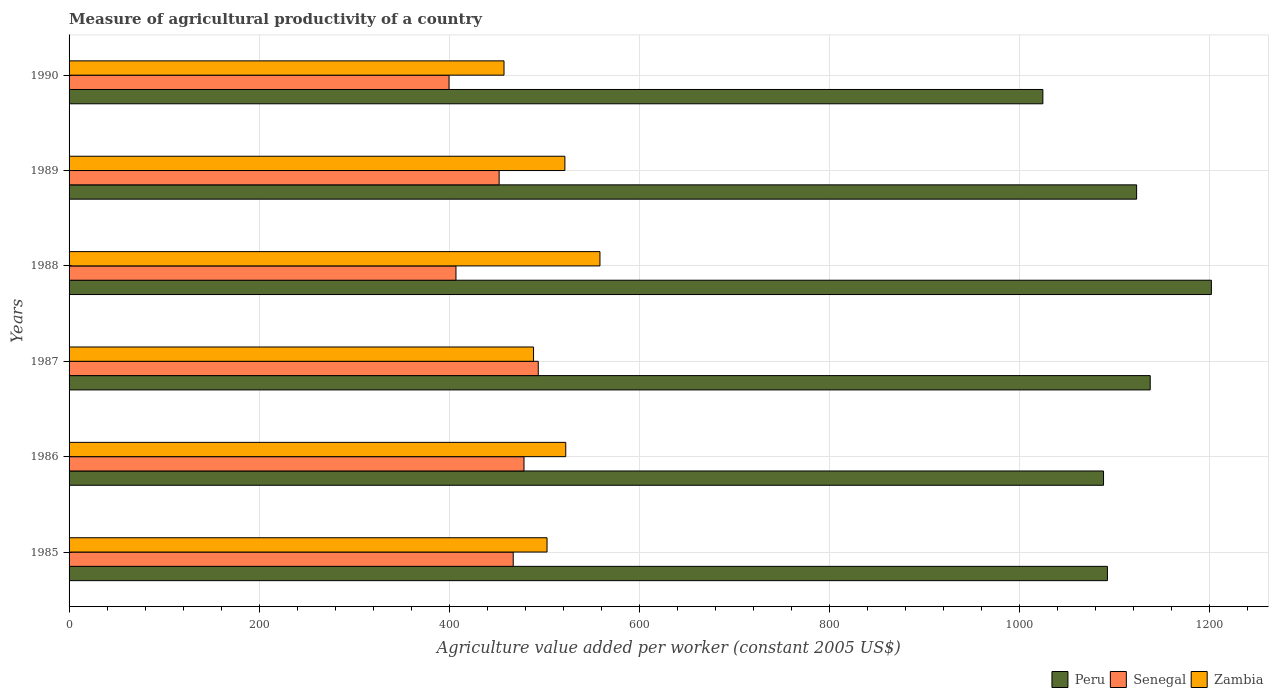How many different coloured bars are there?
Provide a short and direct response. 3. Are the number of bars on each tick of the Y-axis equal?
Offer a terse response. Yes. How many bars are there on the 4th tick from the top?
Keep it short and to the point. 3. What is the label of the 1st group of bars from the top?
Offer a terse response. 1990. What is the measure of agricultural productivity in Senegal in 1990?
Make the answer very short. 399.78. Across all years, what is the maximum measure of agricultural productivity in Senegal?
Give a very brief answer. 493.64. Across all years, what is the minimum measure of agricultural productivity in Zambia?
Provide a short and direct response. 457.6. What is the total measure of agricultural productivity in Senegal in the graph?
Provide a short and direct response. 2698.88. What is the difference between the measure of agricultural productivity in Peru in 1986 and that in 1987?
Give a very brief answer. -49.12. What is the difference between the measure of agricultural productivity in Senegal in 1985 and the measure of agricultural productivity in Zambia in 1989?
Your response must be concise. -54.36. What is the average measure of agricultural productivity in Zambia per year?
Offer a very short reply. 508.65. In the year 1988, what is the difference between the measure of agricultural productivity in Senegal and measure of agricultural productivity in Zambia?
Give a very brief answer. -151.48. In how many years, is the measure of agricultural productivity in Peru greater than 1080 US$?
Provide a succinct answer. 5. What is the ratio of the measure of agricultural productivity in Zambia in 1985 to that in 1987?
Provide a succinct answer. 1.03. Is the measure of agricultural productivity in Zambia in 1986 less than that in 1988?
Provide a short and direct response. Yes. Is the difference between the measure of agricultural productivity in Senegal in 1986 and 1987 greater than the difference between the measure of agricultural productivity in Zambia in 1986 and 1987?
Your answer should be compact. No. What is the difference between the highest and the second highest measure of agricultural productivity in Zambia?
Offer a very short reply. 35.99. What is the difference between the highest and the lowest measure of agricultural productivity in Senegal?
Your response must be concise. 93.86. Is the sum of the measure of agricultural productivity in Senegal in 1989 and 1990 greater than the maximum measure of agricultural productivity in Peru across all years?
Your answer should be very brief. No. Is it the case that in every year, the sum of the measure of agricultural productivity in Zambia and measure of agricultural productivity in Peru is greater than the measure of agricultural productivity in Senegal?
Your answer should be very brief. Yes. Does the graph contain any zero values?
Your answer should be compact. No. Does the graph contain grids?
Give a very brief answer. Yes. How many legend labels are there?
Keep it short and to the point. 3. How are the legend labels stacked?
Ensure brevity in your answer.  Horizontal. What is the title of the graph?
Give a very brief answer. Measure of agricultural productivity of a country. Does "Small states" appear as one of the legend labels in the graph?
Provide a short and direct response. No. What is the label or title of the X-axis?
Make the answer very short. Agriculture value added per worker (constant 2005 US$). What is the label or title of the Y-axis?
Your answer should be very brief. Years. What is the Agriculture value added per worker (constant 2005 US$) in Peru in 1985?
Keep it short and to the point. 1092.45. What is the Agriculture value added per worker (constant 2005 US$) in Senegal in 1985?
Your response must be concise. 467.29. What is the Agriculture value added per worker (constant 2005 US$) in Zambia in 1985?
Give a very brief answer. 502.87. What is the Agriculture value added per worker (constant 2005 US$) of Peru in 1986?
Your answer should be compact. 1088.36. What is the Agriculture value added per worker (constant 2005 US$) of Senegal in 1986?
Make the answer very short. 478.63. What is the Agriculture value added per worker (constant 2005 US$) of Zambia in 1986?
Keep it short and to the point. 522.55. What is the Agriculture value added per worker (constant 2005 US$) of Peru in 1987?
Offer a very short reply. 1137.48. What is the Agriculture value added per worker (constant 2005 US$) in Senegal in 1987?
Ensure brevity in your answer.  493.64. What is the Agriculture value added per worker (constant 2005 US$) of Zambia in 1987?
Provide a succinct answer. 488.67. What is the Agriculture value added per worker (constant 2005 US$) in Peru in 1988?
Offer a terse response. 1201.82. What is the Agriculture value added per worker (constant 2005 US$) of Senegal in 1988?
Your answer should be compact. 407.06. What is the Agriculture value added per worker (constant 2005 US$) of Zambia in 1988?
Ensure brevity in your answer.  558.54. What is the Agriculture value added per worker (constant 2005 US$) in Peru in 1989?
Give a very brief answer. 1123.18. What is the Agriculture value added per worker (constant 2005 US$) of Senegal in 1989?
Provide a short and direct response. 452.48. What is the Agriculture value added per worker (constant 2005 US$) of Zambia in 1989?
Ensure brevity in your answer.  521.65. What is the Agriculture value added per worker (constant 2005 US$) of Peru in 1990?
Provide a short and direct response. 1024.55. What is the Agriculture value added per worker (constant 2005 US$) of Senegal in 1990?
Your answer should be compact. 399.78. What is the Agriculture value added per worker (constant 2005 US$) in Zambia in 1990?
Your response must be concise. 457.6. Across all years, what is the maximum Agriculture value added per worker (constant 2005 US$) in Peru?
Your answer should be very brief. 1201.82. Across all years, what is the maximum Agriculture value added per worker (constant 2005 US$) of Senegal?
Your response must be concise. 493.64. Across all years, what is the maximum Agriculture value added per worker (constant 2005 US$) in Zambia?
Make the answer very short. 558.54. Across all years, what is the minimum Agriculture value added per worker (constant 2005 US$) in Peru?
Your answer should be compact. 1024.55. Across all years, what is the minimum Agriculture value added per worker (constant 2005 US$) of Senegal?
Provide a short and direct response. 399.78. Across all years, what is the minimum Agriculture value added per worker (constant 2005 US$) of Zambia?
Give a very brief answer. 457.6. What is the total Agriculture value added per worker (constant 2005 US$) of Peru in the graph?
Your answer should be compact. 6667.84. What is the total Agriculture value added per worker (constant 2005 US$) in Senegal in the graph?
Offer a very short reply. 2698.88. What is the total Agriculture value added per worker (constant 2005 US$) in Zambia in the graph?
Provide a succinct answer. 3051.89. What is the difference between the Agriculture value added per worker (constant 2005 US$) of Peru in 1985 and that in 1986?
Provide a short and direct response. 4.08. What is the difference between the Agriculture value added per worker (constant 2005 US$) of Senegal in 1985 and that in 1986?
Your answer should be compact. -11.34. What is the difference between the Agriculture value added per worker (constant 2005 US$) in Zambia in 1985 and that in 1986?
Provide a succinct answer. -19.68. What is the difference between the Agriculture value added per worker (constant 2005 US$) in Peru in 1985 and that in 1987?
Provide a short and direct response. -45.03. What is the difference between the Agriculture value added per worker (constant 2005 US$) of Senegal in 1985 and that in 1987?
Make the answer very short. -26.35. What is the difference between the Agriculture value added per worker (constant 2005 US$) in Zambia in 1985 and that in 1987?
Give a very brief answer. 14.2. What is the difference between the Agriculture value added per worker (constant 2005 US$) of Peru in 1985 and that in 1988?
Ensure brevity in your answer.  -109.38. What is the difference between the Agriculture value added per worker (constant 2005 US$) in Senegal in 1985 and that in 1988?
Your answer should be compact. 60.22. What is the difference between the Agriculture value added per worker (constant 2005 US$) of Zambia in 1985 and that in 1988?
Ensure brevity in your answer.  -55.67. What is the difference between the Agriculture value added per worker (constant 2005 US$) in Peru in 1985 and that in 1989?
Offer a very short reply. -30.74. What is the difference between the Agriculture value added per worker (constant 2005 US$) in Senegal in 1985 and that in 1989?
Keep it short and to the point. 14.8. What is the difference between the Agriculture value added per worker (constant 2005 US$) in Zambia in 1985 and that in 1989?
Offer a very short reply. -18.77. What is the difference between the Agriculture value added per worker (constant 2005 US$) of Peru in 1985 and that in 1990?
Offer a terse response. 67.9. What is the difference between the Agriculture value added per worker (constant 2005 US$) in Senegal in 1985 and that in 1990?
Ensure brevity in your answer.  67.51. What is the difference between the Agriculture value added per worker (constant 2005 US$) in Zambia in 1985 and that in 1990?
Provide a short and direct response. 45.27. What is the difference between the Agriculture value added per worker (constant 2005 US$) of Peru in 1986 and that in 1987?
Make the answer very short. -49.12. What is the difference between the Agriculture value added per worker (constant 2005 US$) in Senegal in 1986 and that in 1987?
Keep it short and to the point. -15.01. What is the difference between the Agriculture value added per worker (constant 2005 US$) of Zambia in 1986 and that in 1987?
Provide a short and direct response. 33.88. What is the difference between the Agriculture value added per worker (constant 2005 US$) of Peru in 1986 and that in 1988?
Keep it short and to the point. -113.46. What is the difference between the Agriculture value added per worker (constant 2005 US$) in Senegal in 1986 and that in 1988?
Make the answer very short. 71.57. What is the difference between the Agriculture value added per worker (constant 2005 US$) of Zambia in 1986 and that in 1988?
Offer a very short reply. -35.99. What is the difference between the Agriculture value added per worker (constant 2005 US$) of Peru in 1986 and that in 1989?
Make the answer very short. -34.82. What is the difference between the Agriculture value added per worker (constant 2005 US$) in Senegal in 1986 and that in 1989?
Offer a terse response. 26.15. What is the difference between the Agriculture value added per worker (constant 2005 US$) in Zambia in 1986 and that in 1989?
Your answer should be very brief. 0.9. What is the difference between the Agriculture value added per worker (constant 2005 US$) in Peru in 1986 and that in 1990?
Provide a succinct answer. 63.82. What is the difference between the Agriculture value added per worker (constant 2005 US$) in Senegal in 1986 and that in 1990?
Make the answer very short. 78.85. What is the difference between the Agriculture value added per worker (constant 2005 US$) in Zambia in 1986 and that in 1990?
Keep it short and to the point. 64.95. What is the difference between the Agriculture value added per worker (constant 2005 US$) in Peru in 1987 and that in 1988?
Your response must be concise. -64.34. What is the difference between the Agriculture value added per worker (constant 2005 US$) of Senegal in 1987 and that in 1988?
Offer a terse response. 86.58. What is the difference between the Agriculture value added per worker (constant 2005 US$) of Zambia in 1987 and that in 1988?
Make the answer very short. -69.87. What is the difference between the Agriculture value added per worker (constant 2005 US$) of Peru in 1987 and that in 1989?
Your response must be concise. 14.3. What is the difference between the Agriculture value added per worker (constant 2005 US$) in Senegal in 1987 and that in 1989?
Ensure brevity in your answer.  41.16. What is the difference between the Agriculture value added per worker (constant 2005 US$) of Zambia in 1987 and that in 1989?
Make the answer very short. -32.97. What is the difference between the Agriculture value added per worker (constant 2005 US$) in Peru in 1987 and that in 1990?
Your answer should be very brief. 112.93. What is the difference between the Agriculture value added per worker (constant 2005 US$) in Senegal in 1987 and that in 1990?
Make the answer very short. 93.86. What is the difference between the Agriculture value added per worker (constant 2005 US$) of Zambia in 1987 and that in 1990?
Make the answer very short. 31.07. What is the difference between the Agriculture value added per worker (constant 2005 US$) of Peru in 1988 and that in 1989?
Provide a short and direct response. 78.64. What is the difference between the Agriculture value added per worker (constant 2005 US$) in Senegal in 1988 and that in 1989?
Your answer should be very brief. -45.42. What is the difference between the Agriculture value added per worker (constant 2005 US$) in Zambia in 1988 and that in 1989?
Your answer should be compact. 36.9. What is the difference between the Agriculture value added per worker (constant 2005 US$) of Peru in 1988 and that in 1990?
Give a very brief answer. 177.28. What is the difference between the Agriculture value added per worker (constant 2005 US$) in Senegal in 1988 and that in 1990?
Provide a short and direct response. 7.28. What is the difference between the Agriculture value added per worker (constant 2005 US$) of Zambia in 1988 and that in 1990?
Offer a very short reply. 100.94. What is the difference between the Agriculture value added per worker (constant 2005 US$) in Peru in 1989 and that in 1990?
Make the answer very short. 98.64. What is the difference between the Agriculture value added per worker (constant 2005 US$) in Senegal in 1989 and that in 1990?
Give a very brief answer. 52.7. What is the difference between the Agriculture value added per worker (constant 2005 US$) of Zambia in 1989 and that in 1990?
Offer a terse response. 64.04. What is the difference between the Agriculture value added per worker (constant 2005 US$) in Peru in 1985 and the Agriculture value added per worker (constant 2005 US$) in Senegal in 1986?
Keep it short and to the point. 613.82. What is the difference between the Agriculture value added per worker (constant 2005 US$) in Peru in 1985 and the Agriculture value added per worker (constant 2005 US$) in Zambia in 1986?
Provide a short and direct response. 569.9. What is the difference between the Agriculture value added per worker (constant 2005 US$) in Senegal in 1985 and the Agriculture value added per worker (constant 2005 US$) in Zambia in 1986?
Ensure brevity in your answer.  -55.26. What is the difference between the Agriculture value added per worker (constant 2005 US$) of Peru in 1985 and the Agriculture value added per worker (constant 2005 US$) of Senegal in 1987?
Ensure brevity in your answer.  598.81. What is the difference between the Agriculture value added per worker (constant 2005 US$) of Peru in 1985 and the Agriculture value added per worker (constant 2005 US$) of Zambia in 1987?
Offer a very short reply. 603.77. What is the difference between the Agriculture value added per worker (constant 2005 US$) of Senegal in 1985 and the Agriculture value added per worker (constant 2005 US$) of Zambia in 1987?
Your response must be concise. -21.39. What is the difference between the Agriculture value added per worker (constant 2005 US$) of Peru in 1985 and the Agriculture value added per worker (constant 2005 US$) of Senegal in 1988?
Keep it short and to the point. 685.38. What is the difference between the Agriculture value added per worker (constant 2005 US$) of Peru in 1985 and the Agriculture value added per worker (constant 2005 US$) of Zambia in 1988?
Ensure brevity in your answer.  533.9. What is the difference between the Agriculture value added per worker (constant 2005 US$) in Senegal in 1985 and the Agriculture value added per worker (constant 2005 US$) in Zambia in 1988?
Your answer should be very brief. -91.26. What is the difference between the Agriculture value added per worker (constant 2005 US$) of Peru in 1985 and the Agriculture value added per worker (constant 2005 US$) of Senegal in 1989?
Provide a succinct answer. 639.96. What is the difference between the Agriculture value added per worker (constant 2005 US$) of Peru in 1985 and the Agriculture value added per worker (constant 2005 US$) of Zambia in 1989?
Your answer should be very brief. 570.8. What is the difference between the Agriculture value added per worker (constant 2005 US$) of Senegal in 1985 and the Agriculture value added per worker (constant 2005 US$) of Zambia in 1989?
Provide a succinct answer. -54.36. What is the difference between the Agriculture value added per worker (constant 2005 US$) in Peru in 1985 and the Agriculture value added per worker (constant 2005 US$) in Senegal in 1990?
Your answer should be very brief. 692.67. What is the difference between the Agriculture value added per worker (constant 2005 US$) in Peru in 1985 and the Agriculture value added per worker (constant 2005 US$) in Zambia in 1990?
Ensure brevity in your answer.  634.84. What is the difference between the Agriculture value added per worker (constant 2005 US$) of Senegal in 1985 and the Agriculture value added per worker (constant 2005 US$) of Zambia in 1990?
Ensure brevity in your answer.  9.68. What is the difference between the Agriculture value added per worker (constant 2005 US$) in Peru in 1986 and the Agriculture value added per worker (constant 2005 US$) in Senegal in 1987?
Keep it short and to the point. 594.72. What is the difference between the Agriculture value added per worker (constant 2005 US$) in Peru in 1986 and the Agriculture value added per worker (constant 2005 US$) in Zambia in 1987?
Your response must be concise. 599.69. What is the difference between the Agriculture value added per worker (constant 2005 US$) in Senegal in 1986 and the Agriculture value added per worker (constant 2005 US$) in Zambia in 1987?
Provide a short and direct response. -10.04. What is the difference between the Agriculture value added per worker (constant 2005 US$) of Peru in 1986 and the Agriculture value added per worker (constant 2005 US$) of Senegal in 1988?
Ensure brevity in your answer.  681.3. What is the difference between the Agriculture value added per worker (constant 2005 US$) in Peru in 1986 and the Agriculture value added per worker (constant 2005 US$) in Zambia in 1988?
Your response must be concise. 529.82. What is the difference between the Agriculture value added per worker (constant 2005 US$) of Senegal in 1986 and the Agriculture value added per worker (constant 2005 US$) of Zambia in 1988?
Keep it short and to the point. -79.91. What is the difference between the Agriculture value added per worker (constant 2005 US$) of Peru in 1986 and the Agriculture value added per worker (constant 2005 US$) of Senegal in 1989?
Offer a terse response. 635.88. What is the difference between the Agriculture value added per worker (constant 2005 US$) of Peru in 1986 and the Agriculture value added per worker (constant 2005 US$) of Zambia in 1989?
Ensure brevity in your answer.  566.72. What is the difference between the Agriculture value added per worker (constant 2005 US$) in Senegal in 1986 and the Agriculture value added per worker (constant 2005 US$) in Zambia in 1989?
Your answer should be very brief. -43.02. What is the difference between the Agriculture value added per worker (constant 2005 US$) in Peru in 1986 and the Agriculture value added per worker (constant 2005 US$) in Senegal in 1990?
Your response must be concise. 688.58. What is the difference between the Agriculture value added per worker (constant 2005 US$) in Peru in 1986 and the Agriculture value added per worker (constant 2005 US$) in Zambia in 1990?
Provide a succinct answer. 630.76. What is the difference between the Agriculture value added per worker (constant 2005 US$) of Senegal in 1986 and the Agriculture value added per worker (constant 2005 US$) of Zambia in 1990?
Your answer should be compact. 21.03. What is the difference between the Agriculture value added per worker (constant 2005 US$) in Peru in 1987 and the Agriculture value added per worker (constant 2005 US$) in Senegal in 1988?
Offer a terse response. 730.42. What is the difference between the Agriculture value added per worker (constant 2005 US$) in Peru in 1987 and the Agriculture value added per worker (constant 2005 US$) in Zambia in 1988?
Your answer should be compact. 578.93. What is the difference between the Agriculture value added per worker (constant 2005 US$) in Senegal in 1987 and the Agriculture value added per worker (constant 2005 US$) in Zambia in 1988?
Offer a very short reply. -64.9. What is the difference between the Agriculture value added per worker (constant 2005 US$) in Peru in 1987 and the Agriculture value added per worker (constant 2005 US$) in Senegal in 1989?
Make the answer very short. 685. What is the difference between the Agriculture value added per worker (constant 2005 US$) of Peru in 1987 and the Agriculture value added per worker (constant 2005 US$) of Zambia in 1989?
Keep it short and to the point. 615.83. What is the difference between the Agriculture value added per worker (constant 2005 US$) of Senegal in 1987 and the Agriculture value added per worker (constant 2005 US$) of Zambia in 1989?
Your response must be concise. -28.01. What is the difference between the Agriculture value added per worker (constant 2005 US$) in Peru in 1987 and the Agriculture value added per worker (constant 2005 US$) in Senegal in 1990?
Ensure brevity in your answer.  737.7. What is the difference between the Agriculture value added per worker (constant 2005 US$) of Peru in 1987 and the Agriculture value added per worker (constant 2005 US$) of Zambia in 1990?
Provide a short and direct response. 679.87. What is the difference between the Agriculture value added per worker (constant 2005 US$) in Senegal in 1987 and the Agriculture value added per worker (constant 2005 US$) in Zambia in 1990?
Keep it short and to the point. 36.04. What is the difference between the Agriculture value added per worker (constant 2005 US$) in Peru in 1988 and the Agriculture value added per worker (constant 2005 US$) in Senegal in 1989?
Your answer should be compact. 749.34. What is the difference between the Agriculture value added per worker (constant 2005 US$) of Peru in 1988 and the Agriculture value added per worker (constant 2005 US$) of Zambia in 1989?
Keep it short and to the point. 680.17. What is the difference between the Agriculture value added per worker (constant 2005 US$) in Senegal in 1988 and the Agriculture value added per worker (constant 2005 US$) in Zambia in 1989?
Your response must be concise. -114.58. What is the difference between the Agriculture value added per worker (constant 2005 US$) of Peru in 1988 and the Agriculture value added per worker (constant 2005 US$) of Senegal in 1990?
Offer a very short reply. 802.04. What is the difference between the Agriculture value added per worker (constant 2005 US$) of Peru in 1988 and the Agriculture value added per worker (constant 2005 US$) of Zambia in 1990?
Keep it short and to the point. 744.22. What is the difference between the Agriculture value added per worker (constant 2005 US$) in Senegal in 1988 and the Agriculture value added per worker (constant 2005 US$) in Zambia in 1990?
Offer a very short reply. -50.54. What is the difference between the Agriculture value added per worker (constant 2005 US$) of Peru in 1989 and the Agriculture value added per worker (constant 2005 US$) of Senegal in 1990?
Make the answer very short. 723.4. What is the difference between the Agriculture value added per worker (constant 2005 US$) in Peru in 1989 and the Agriculture value added per worker (constant 2005 US$) in Zambia in 1990?
Give a very brief answer. 665.58. What is the difference between the Agriculture value added per worker (constant 2005 US$) in Senegal in 1989 and the Agriculture value added per worker (constant 2005 US$) in Zambia in 1990?
Provide a short and direct response. -5.12. What is the average Agriculture value added per worker (constant 2005 US$) in Peru per year?
Your answer should be compact. 1111.31. What is the average Agriculture value added per worker (constant 2005 US$) in Senegal per year?
Provide a succinct answer. 449.81. What is the average Agriculture value added per worker (constant 2005 US$) of Zambia per year?
Offer a very short reply. 508.65. In the year 1985, what is the difference between the Agriculture value added per worker (constant 2005 US$) of Peru and Agriculture value added per worker (constant 2005 US$) of Senegal?
Provide a short and direct response. 625.16. In the year 1985, what is the difference between the Agriculture value added per worker (constant 2005 US$) in Peru and Agriculture value added per worker (constant 2005 US$) in Zambia?
Your answer should be very brief. 589.57. In the year 1985, what is the difference between the Agriculture value added per worker (constant 2005 US$) in Senegal and Agriculture value added per worker (constant 2005 US$) in Zambia?
Offer a terse response. -35.59. In the year 1986, what is the difference between the Agriculture value added per worker (constant 2005 US$) in Peru and Agriculture value added per worker (constant 2005 US$) in Senegal?
Your answer should be compact. 609.73. In the year 1986, what is the difference between the Agriculture value added per worker (constant 2005 US$) in Peru and Agriculture value added per worker (constant 2005 US$) in Zambia?
Provide a succinct answer. 565.81. In the year 1986, what is the difference between the Agriculture value added per worker (constant 2005 US$) of Senegal and Agriculture value added per worker (constant 2005 US$) of Zambia?
Keep it short and to the point. -43.92. In the year 1987, what is the difference between the Agriculture value added per worker (constant 2005 US$) in Peru and Agriculture value added per worker (constant 2005 US$) in Senegal?
Give a very brief answer. 643.84. In the year 1987, what is the difference between the Agriculture value added per worker (constant 2005 US$) in Peru and Agriculture value added per worker (constant 2005 US$) in Zambia?
Your answer should be very brief. 648.81. In the year 1987, what is the difference between the Agriculture value added per worker (constant 2005 US$) of Senegal and Agriculture value added per worker (constant 2005 US$) of Zambia?
Provide a succinct answer. 4.97. In the year 1988, what is the difference between the Agriculture value added per worker (constant 2005 US$) of Peru and Agriculture value added per worker (constant 2005 US$) of Senegal?
Provide a short and direct response. 794.76. In the year 1988, what is the difference between the Agriculture value added per worker (constant 2005 US$) in Peru and Agriculture value added per worker (constant 2005 US$) in Zambia?
Keep it short and to the point. 643.28. In the year 1988, what is the difference between the Agriculture value added per worker (constant 2005 US$) in Senegal and Agriculture value added per worker (constant 2005 US$) in Zambia?
Offer a very short reply. -151.48. In the year 1989, what is the difference between the Agriculture value added per worker (constant 2005 US$) in Peru and Agriculture value added per worker (constant 2005 US$) in Senegal?
Your answer should be very brief. 670.7. In the year 1989, what is the difference between the Agriculture value added per worker (constant 2005 US$) in Peru and Agriculture value added per worker (constant 2005 US$) in Zambia?
Provide a succinct answer. 601.54. In the year 1989, what is the difference between the Agriculture value added per worker (constant 2005 US$) of Senegal and Agriculture value added per worker (constant 2005 US$) of Zambia?
Keep it short and to the point. -69.16. In the year 1990, what is the difference between the Agriculture value added per worker (constant 2005 US$) in Peru and Agriculture value added per worker (constant 2005 US$) in Senegal?
Your answer should be compact. 624.77. In the year 1990, what is the difference between the Agriculture value added per worker (constant 2005 US$) of Peru and Agriculture value added per worker (constant 2005 US$) of Zambia?
Offer a terse response. 566.94. In the year 1990, what is the difference between the Agriculture value added per worker (constant 2005 US$) of Senegal and Agriculture value added per worker (constant 2005 US$) of Zambia?
Your answer should be compact. -57.83. What is the ratio of the Agriculture value added per worker (constant 2005 US$) in Senegal in 1985 to that in 1986?
Your answer should be very brief. 0.98. What is the ratio of the Agriculture value added per worker (constant 2005 US$) of Zambia in 1985 to that in 1986?
Make the answer very short. 0.96. What is the ratio of the Agriculture value added per worker (constant 2005 US$) of Peru in 1985 to that in 1987?
Ensure brevity in your answer.  0.96. What is the ratio of the Agriculture value added per worker (constant 2005 US$) of Senegal in 1985 to that in 1987?
Offer a terse response. 0.95. What is the ratio of the Agriculture value added per worker (constant 2005 US$) of Zambia in 1985 to that in 1987?
Ensure brevity in your answer.  1.03. What is the ratio of the Agriculture value added per worker (constant 2005 US$) in Peru in 1985 to that in 1988?
Give a very brief answer. 0.91. What is the ratio of the Agriculture value added per worker (constant 2005 US$) in Senegal in 1985 to that in 1988?
Your answer should be compact. 1.15. What is the ratio of the Agriculture value added per worker (constant 2005 US$) of Zambia in 1985 to that in 1988?
Keep it short and to the point. 0.9. What is the ratio of the Agriculture value added per worker (constant 2005 US$) in Peru in 1985 to that in 1989?
Ensure brevity in your answer.  0.97. What is the ratio of the Agriculture value added per worker (constant 2005 US$) in Senegal in 1985 to that in 1989?
Ensure brevity in your answer.  1.03. What is the ratio of the Agriculture value added per worker (constant 2005 US$) in Zambia in 1985 to that in 1989?
Your response must be concise. 0.96. What is the ratio of the Agriculture value added per worker (constant 2005 US$) in Peru in 1985 to that in 1990?
Ensure brevity in your answer.  1.07. What is the ratio of the Agriculture value added per worker (constant 2005 US$) of Senegal in 1985 to that in 1990?
Your answer should be very brief. 1.17. What is the ratio of the Agriculture value added per worker (constant 2005 US$) in Zambia in 1985 to that in 1990?
Your answer should be very brief. 1.1. What is the ratio of the Agriculture value added per worker (constant 2005 US$) in Peru in 1986 to that in 1987?
Provide a succinct answer. 0.96. What is the ratio of the Agriculture value added per worker (constant 2005 US$) of Senegal in 1986 to that in 1987?
Offer a terse response. 0.97. What is the ratio of the Agriculture value added per worker (constant 2005 US$) of Zambia in 1986 to that in 1987?
Provide a short and direct response. 1.07. What is the ratio of the Agriculture value added per worker (constant 2005 US$) in Peru in 1986 to that in 1988?
Provide a short and direct response. 0.91. What is the ratio of the Agriculture value added per worker (constant 2005 US$) in Senegal in 1986 to that in 1988?
Provide a short and direct response. 1.18. What is the ratio of the Agriculture value added per worker (constant 2005 US$) of Zambia in 1986 to that in 1988?
Make the answer very short. 0.94. What is the ratio of the Agriculture value added per worker (constant 2005 US$) in Senegal in 1986 to that in 1989?
Offer a very short reply. 1.06. What is the ratio of the Agriculture value added per worker (constant 2005 US$) of Zambia in 1986 to that in 1989?
Offer a terse response. 1. What is the ratio of the Agriculture value added per worker (constant 2005 US$) in Peru in 1986 to that in 1990?
Your answer should be compact. 1.06. What is the ratio of the Agriculture value added per worker (constant 2005 US$) in Senegal in 1986 to that in 1990?
Provide a short and direct response. 1.2. What is the ratio of the Agriculture value added per worker (constant 2005 US$) in Zambia in 1986 to that in 1990?
Offer a very short reply. 1.14. What is the ratio of the Agriculture value added per worker (constant 2005 US$) of Peru in 1987 to that in 1988?
Your answer should be very brief. 0.95. What is the ratio of the Agriculture value added per worker (constant 2005 US$) of Senegal in 1987 to that in 1988?
Offer a terse response. 1.21. What is the ratio of the Agriculture value added per worker (constant 2005 US$) of Zambia in 1987 to that in 1988?
Give a very brief answer. 0.87. What is the ratio of the Agriculture value added per worker (constant 2005 US$) of Peru in 1987 to that in 1989?
Provide a short and direct response. 1.01. What is the ratio of the Agriculture value added per worker (constant 2005 US$) of Senegal in 1987 to that in 1989?
Offer a terse response. 1.09. What is the ratio of the Agriculture value added per worker (constant 2005 US$) of Zambia in 1987 to that in 1989?
Offer a terse response. 0.94. What is the ratio of the Agriculture value added per worker (constant 2005 US$) of Peru in 1987 to that in 1990?
Keep it short and to the point. 1.11. What is the ratio of the Agriculture value added per worker (constant 2005 US$) in Senegal in 1987 to that in 1990?
Provide a succinct answer. 1.23. What is the ratio of the Agriculture value added per worker (constant 2005 US$) of Zambia in 1987 to that in 1990?
Offer a terse response. 1.07. What is the ratio of the Agriculture value added per worker (constant 2005 US$) of Peru in 1988 to that in 1989?
Give a very brief answer. 1.07. What is the ratio of the Agriculture value added per worker (constant 2005 US$) of Senegal in 1988 to that in 1989?
Your answer should be very brief. 0.9. What is the ratio of the Agriculture value added per worker (constant 2005 US$) of Zambia in 1988 to that in 1989?
Provide a succinct answer. 1.07. What is the ratio of the Agriculture value added per worker (constant 2005 US$) in Peru in 1988 to that in 1990?
Provide a short and direct response. 1.17. What is the ratio of the Agriculture value added per worker (constant 2005 US$) in Senegal in 1988 to that in 1990?
Offer a terse response. 1.02. What is the ratio of the Agriculture value added per worker (constant 2005 US$) of Zambia in 1988 to that in 1990?
Ensure brevity in your answer.  1.22. What is the ratio of the Agriculture value added per worker (constant 2005 US$) of Peru in 1989 to that in 1990?
Provide a succinct answer. 1.1. What is the ratio of the Agriculture value added per worker (constant 2005 US$) in Senegal in 1989 to that in 1990?
Give a very brief answer. 1.13. What is the ratio of the Agriculture value added per worker (constant 2005 US$) of Zambia in 1989 to that in 1990?
Offer a terse response. 1.14. What is the difference between the highest and the second highest Agriculture value added per worker (constant 2005 US$) in Peru?
Your answer should be compact. 64.34. What is the difference between the highest and the second highest Agriculture value added per worker (constant 2005 US$) of Senegal?
Ensure brevity in your answer.  15.01. What is the difference between the highest and the second highest Agriculture value added per worker (constant 2005 US$) of Zambia?
Offer a very short reply. 35.99. What is the difference between the highest and the lowest Agriculture value added per worker (constant 2005 US$) of Peru?
Keep it short and to the point. 177.28. What is the difference between the highest and the lowest Agriculture value added per worker (constant 2005 US$) in Senegal?
Your answer should be very brief. 93.86. What is the difference between the highest and the lowest Agriculture value added per worker (constant 2005 US$) in Zambia?
Offer a very short reply. 100.94. 